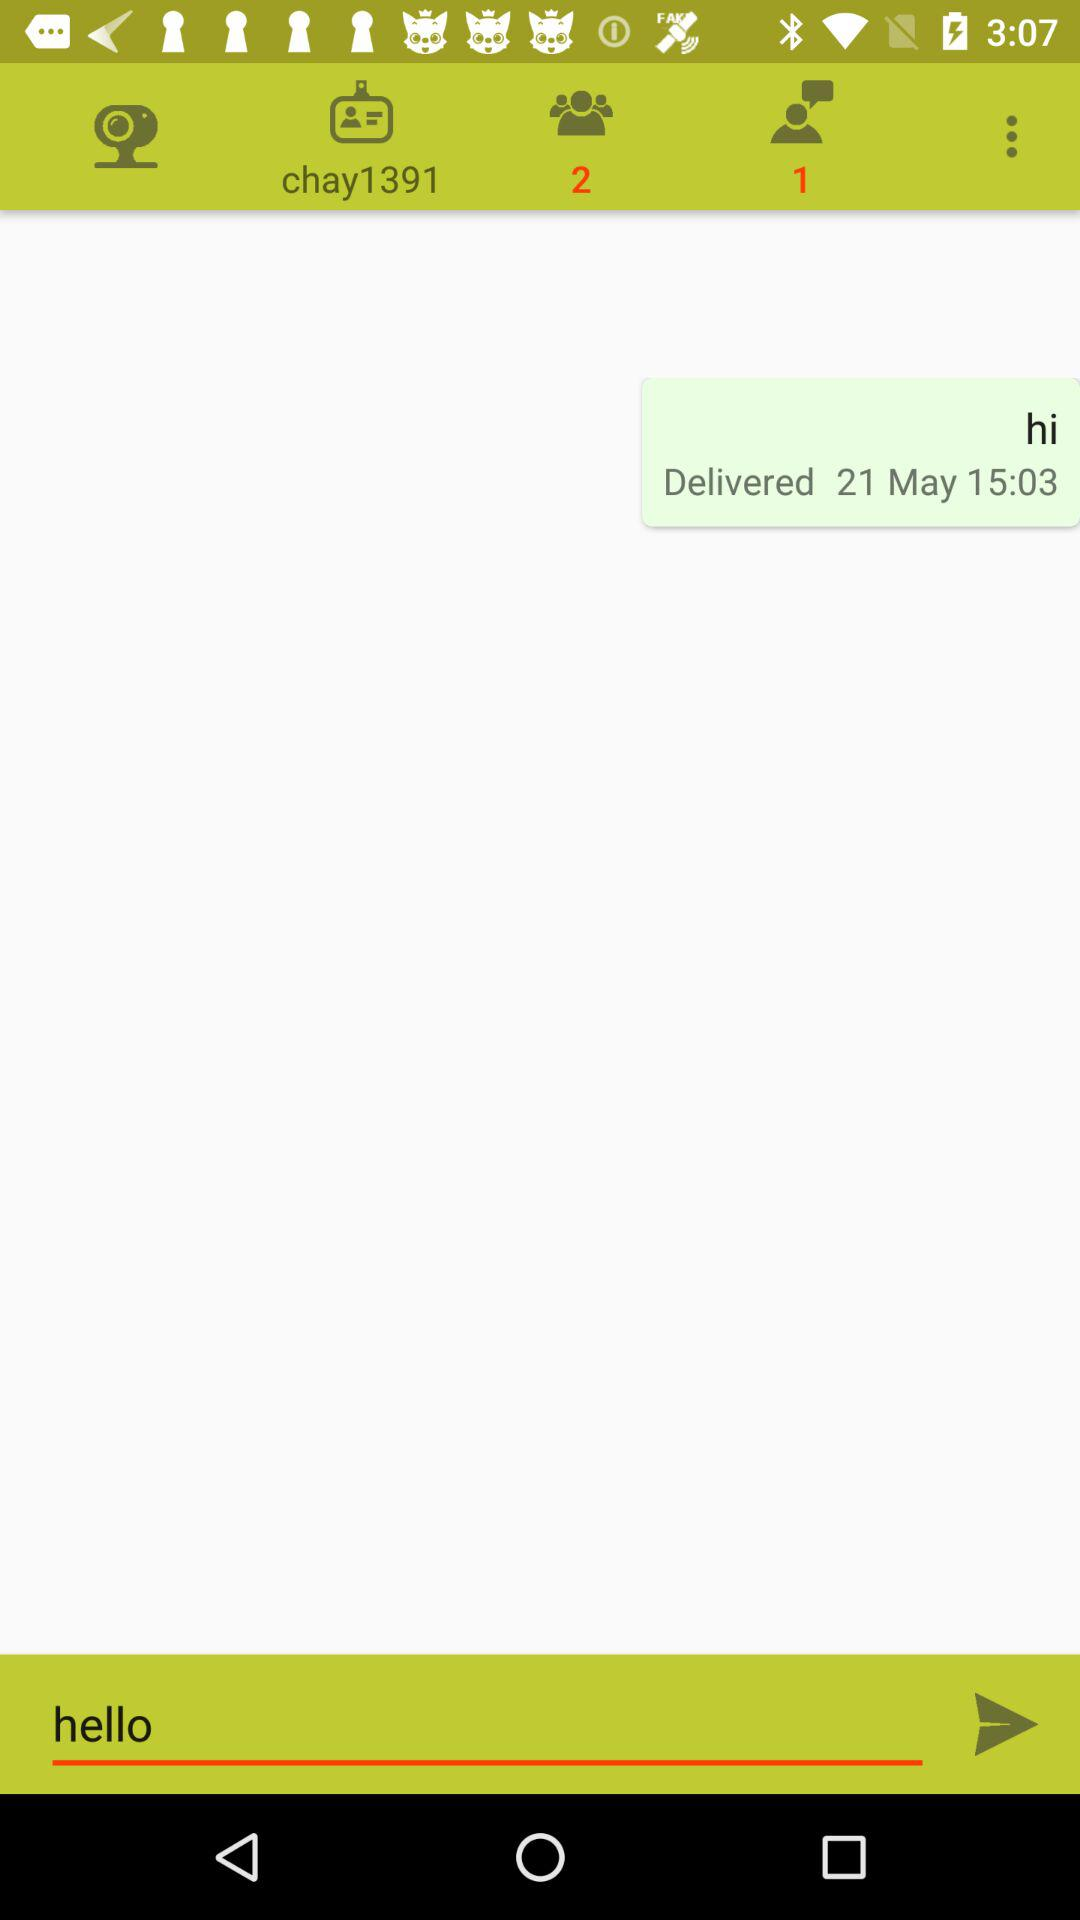How many more people are in the chat than there are unread messages?
Answer the question using a single word or phrase. 1 